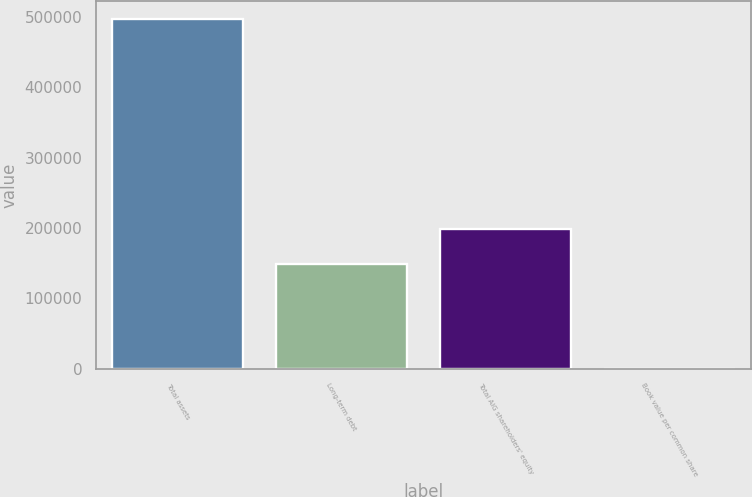Convert chart. <chart><loc_0><loc_0><loc_500><loc_500><bar_chart><fcel>Total assets<fcel>Long-term debt<fcel>Total AIG shareholders' equity<fcel>Book value per common share<nl><fcel>496943<fcel>149124<fcel>198813<fcel>58.94<nl></chart> 